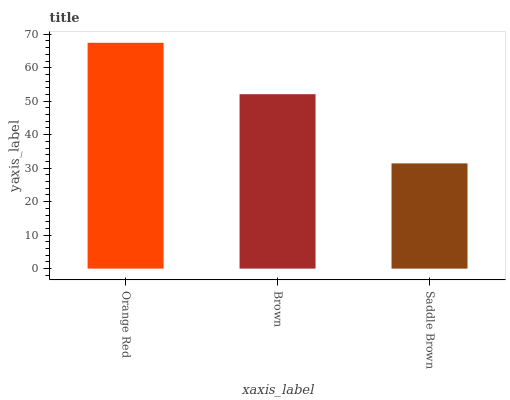Is Saddle Brown the minimum?
Answer yes or no. Yes. Is Orange Red the maximum?
Answer yes or no. Yes. Is Brown the minimum?
Answer yes or no. No. Is Brown the maximum?
Answer yes or no. No. Is Orange Red greater than Brown?
Answer yes or no. Yes. Is Brown less than Orange Red?
Answer yes or no. Yes. Is Brown greater than Orange Red?
Answer yes or no. No. Is Orange Red less than Brown?
Answer yes or no. No. Is Brown the high median?
Answer yes or no. Yes. Is Brown the low median?
Answer yes or no. Yes. Is Saddle Brown the high median?
Answer yes or no. No. Is Orange Red the low median?
Answer yes or no. No. 